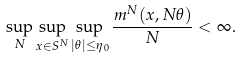Convert formula to latex. <formula><loc_0><loc_0><loc_500><loc_500>\sup _ { N } \sup _ { x \in S ^ { N } } \sup _ { | \theta | \leq \eta _ { 0 } } \frac { m ^ { N } ( x , N \theta ) } { N } < \infty .</formula> 